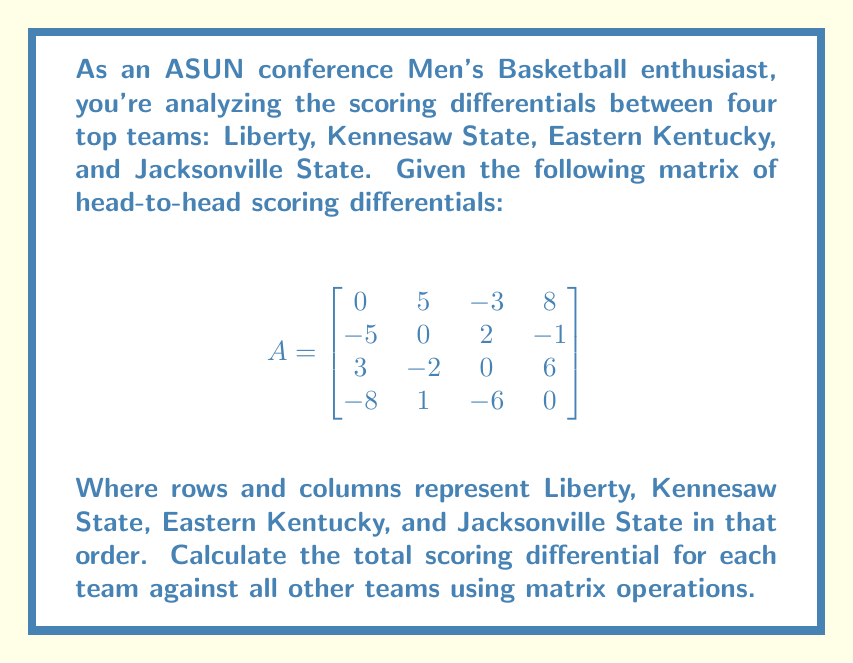Can you answer this question? To solve this problem, we'll follow these steps:

1) First, we need to understand what the matrix represents. Each entry $a_{ij}$ represents the scoring differential of team i against team j. For example, $a_{12} = 5$ means Liberty outscored Kennesaw State by 5 points.

2) To find the total scoring differential for each team, we need to sum up each row of the matrix. We can do this by multiplying our matrix A by a column vector of 1's:

   $$
   \begin{bmatrix}
   0 & 5 & -3 & 8 \\
   -5 & 0 & 2 & -1 \\
   3 & -2 & 0 & 6 \\
   -8 & 1 & -6 & 0
   \end{bmatrix}
   \times
   \begin{bmatrix}
   1 \\ 1 \\ 1 \\ 1
   \end{bmatrix}
   $$

3) Let's perform this matrix multiplication:

   $$
   \begin{bmatrix}
   0 + 5 + (-3) + 8 \\
   (-5) + 0 + 2 + (-1) \\
   3 + (-2) + 0 + 6 \\
   (-8) + 1 + (-6) + 0
   \end{bmatrix}
   =
   \begin{bmatrix}
   10 \\
   -4 \\
   7 \\
   -13
   \end{bmatrix}
   $$

4) The resulting column vector gives us the total scoring differential for each team:
   - Liberty: +10
   - Kennesaw State: -4
   - Eastern Kentucky: +7
   - Jacksonville State: -13
Answer: $[10, -4, 7, -13]$ 